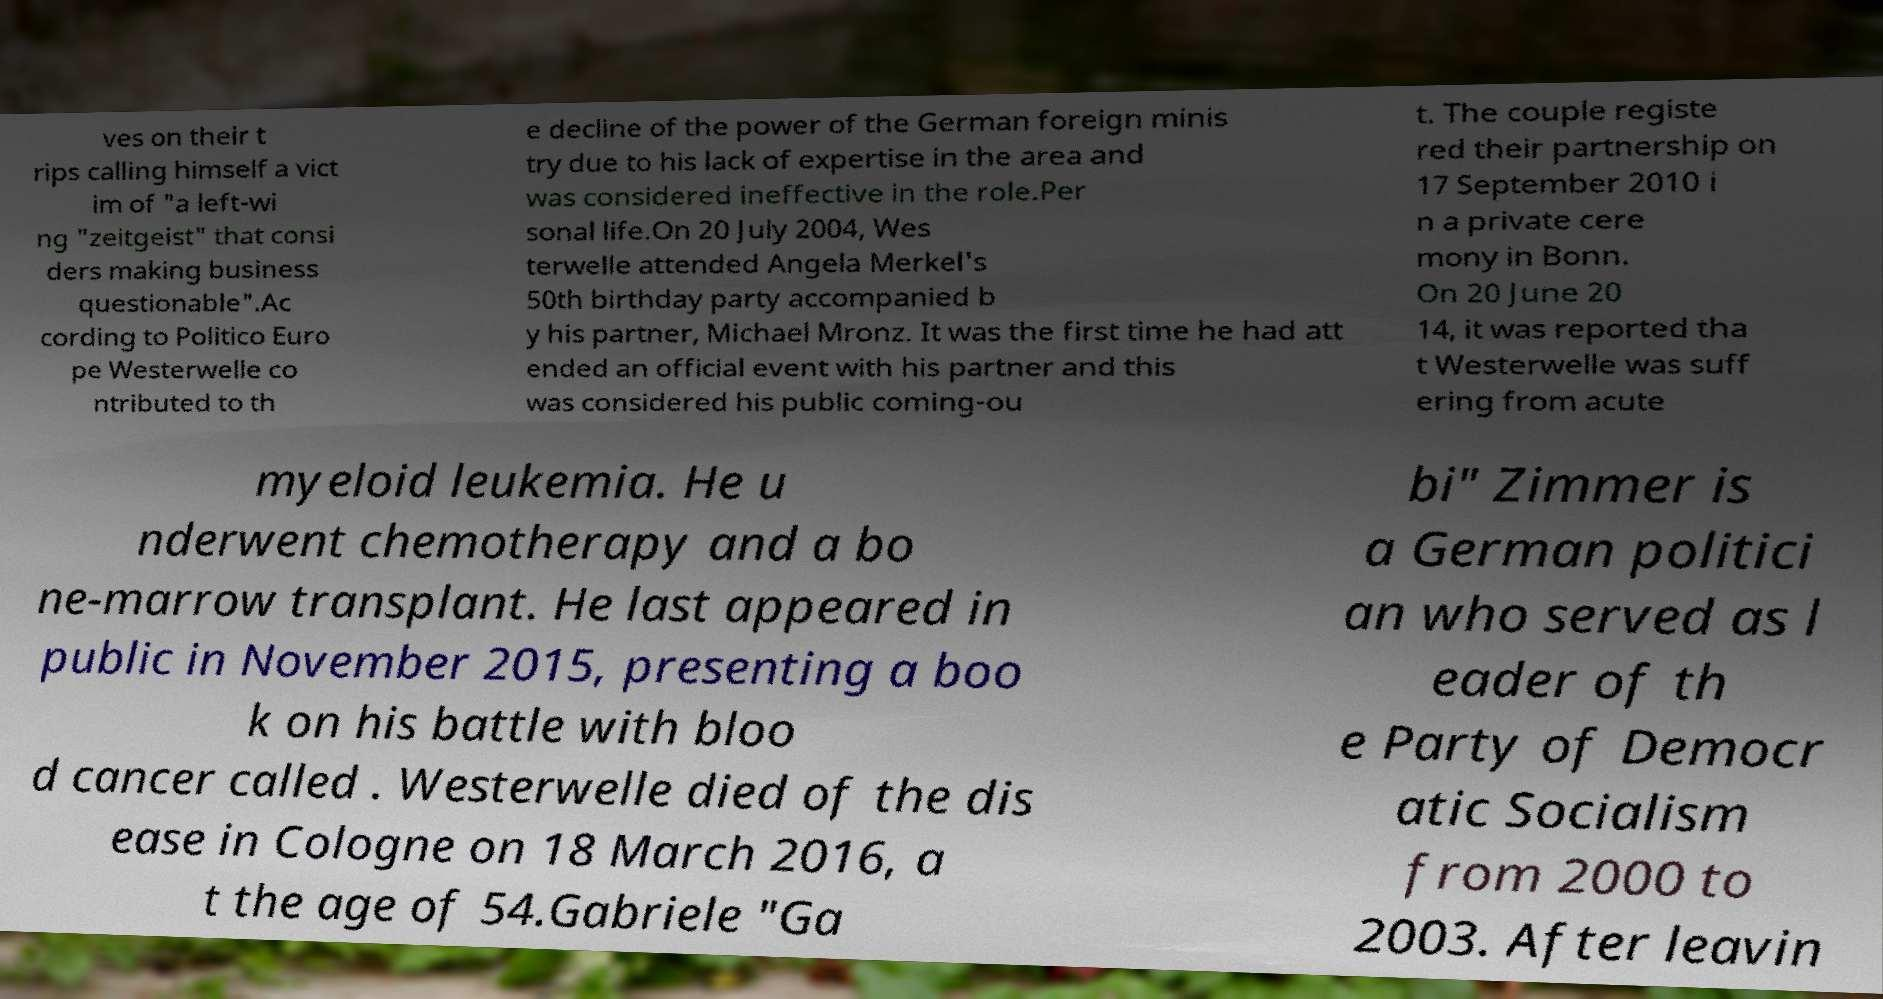Could you extract and type out the text from this image? ves on their t rips calling himself a vict im of "a left-wi ng "zeitgeist" that consi ders making business questionable".Ac cording to Politico Euro pe Westerwelle co ntributed to th e decline of the power of the German foreign minis try due to his lack of expertise in the area and was considered ineffective in the role.Per sonal life.On 20 July 2004, Wes terwelle attended Angela Merkel's 50th birthday party accompanied b y his partner, Michael Mronz. It was the first time he had att ended an official event with his partner and this was considered his public coming-ou t. The couple registe red their partnership on 17 September 2010 i n a private cere mony in Bonn. On 20 June 20 14, it was reported tha t Westerwelle was suff ering from acute myeloid leukemia. He u nderwent chemotherapy and a bo ne-marrow transplant. He last appeared in public in November 2015, presenting a boo k on his battle with bloo d cancer called . Westerwelle died of the dis ease in Cologne on 18 March 2016, a t the age of 54.Gabriele "Ga bi" Zimmer is a German politici an who served as l eader of th e Party of Democr atic Socialism from 2000 to 2003. After leavin 